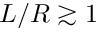<formula> <loc_0><loc_0><loc_500><loc_500>L / R \gtrsim 1</formula> 